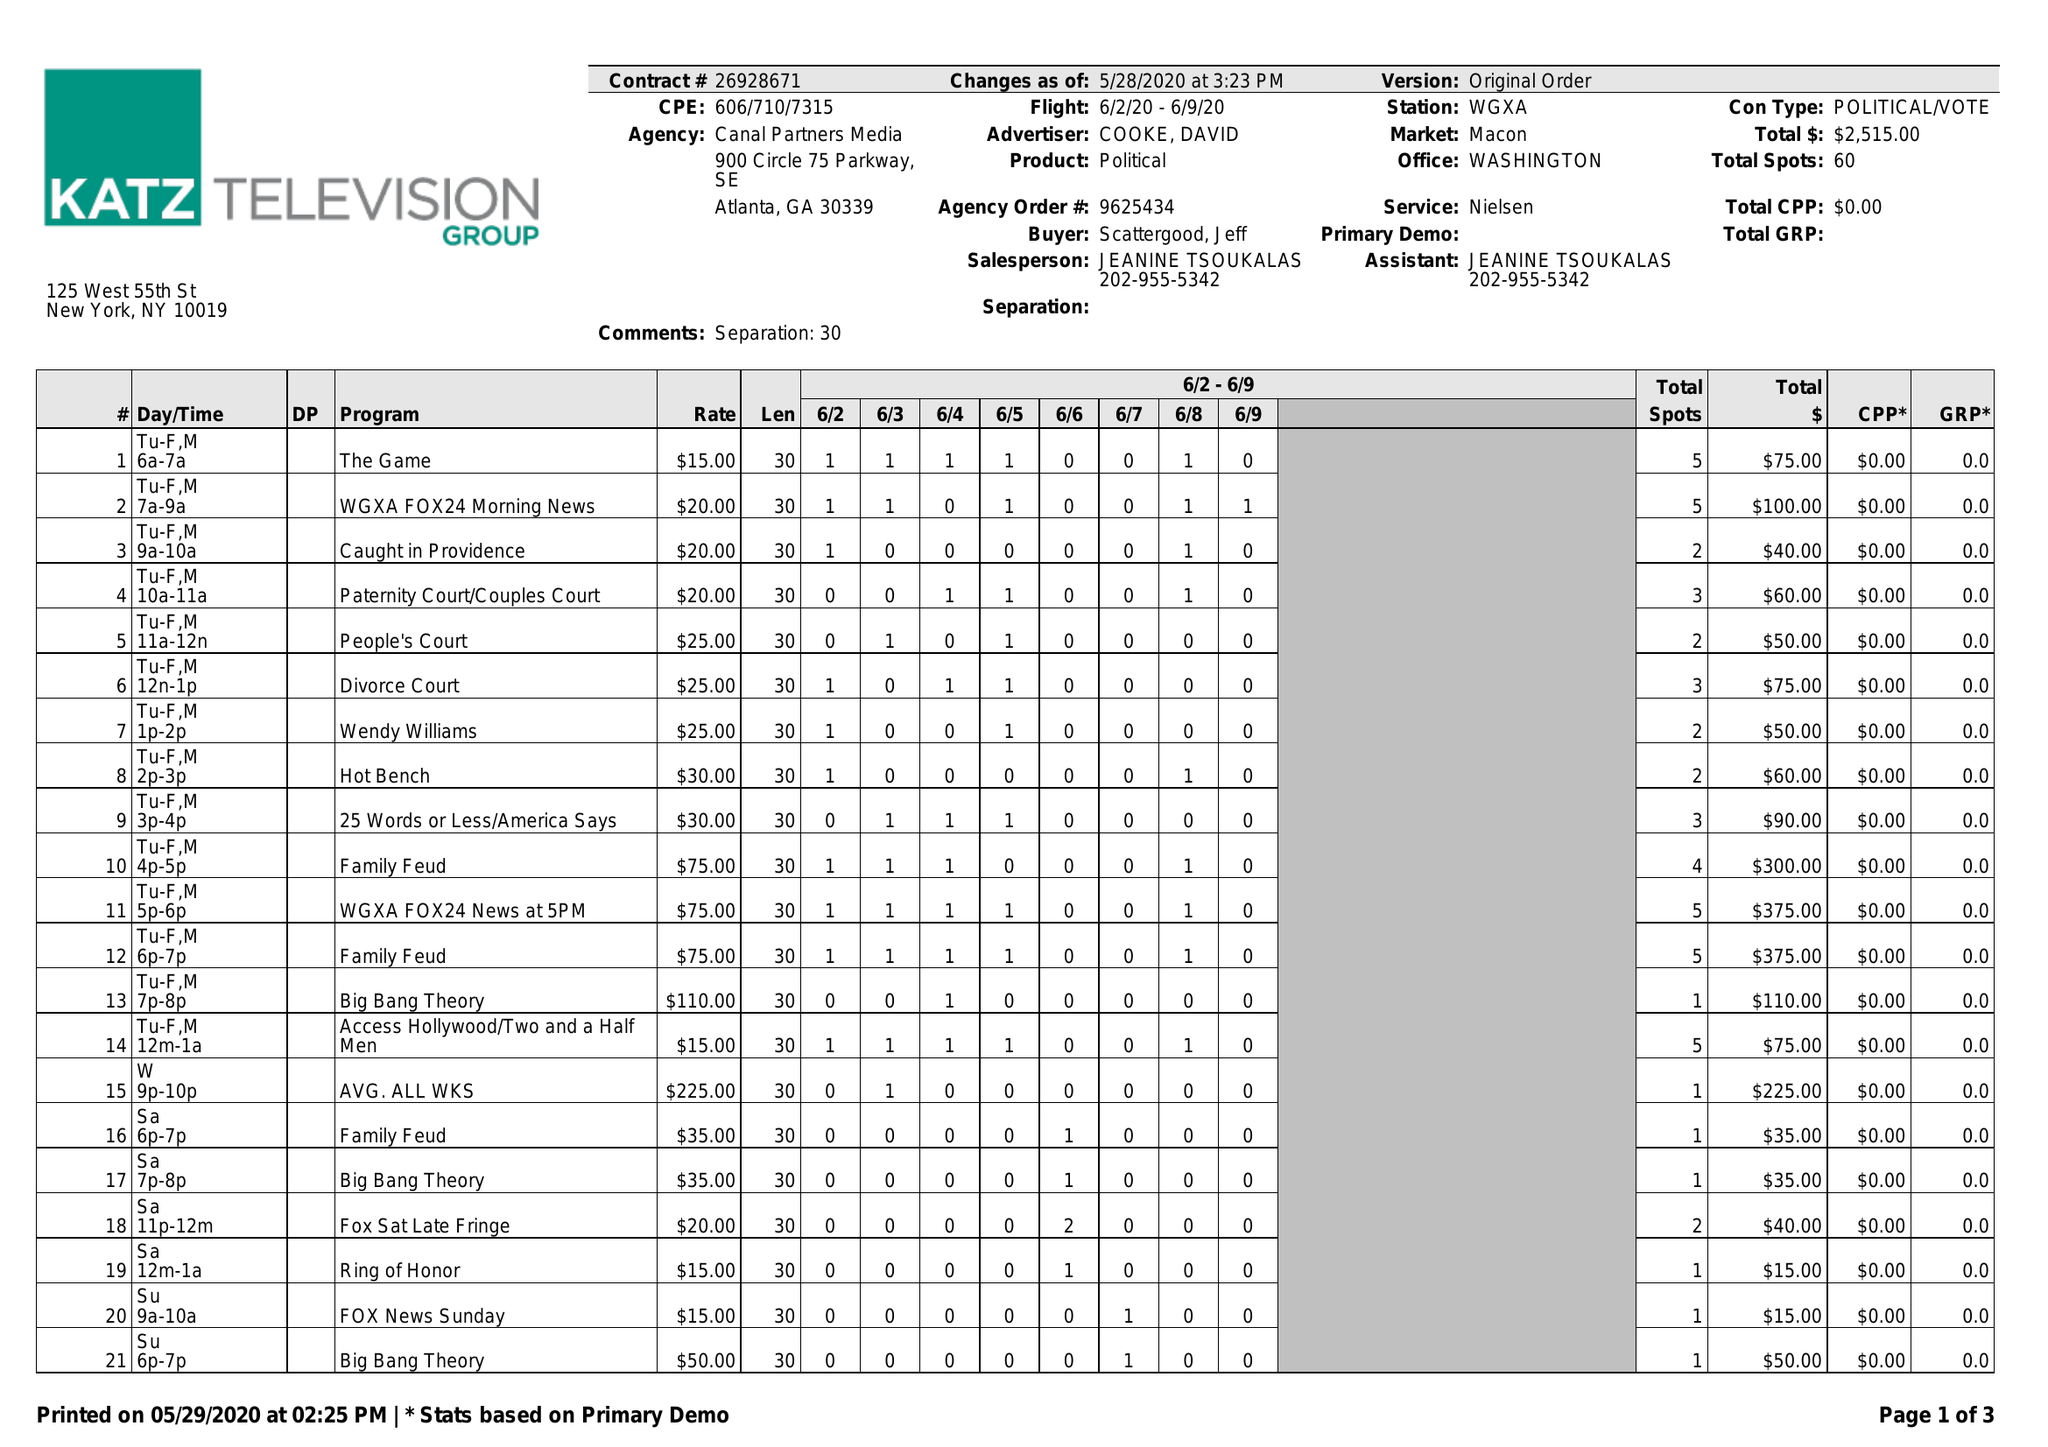What is the value for the contract_num?
Answer the question using a single word or phrase. 26928671 